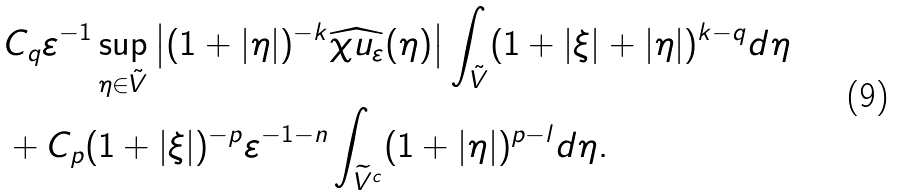<formula> <loc_0><loc_0><loc_500><loc_500>& C _ { q } \varepsilon ^ { - 1 } \sup _ { \eta \in \tilde { V } } \left | ( 1 + | \eta | ) ^ { - k } \widehat { \chi u _ { \varepsilon } } ( \eta ) \right | \int _ { \tilde { V } } ( 1 + | \xi | + | \eta | ) ^ { k - q } d \eta \\ & + C _ { p } ( 1 + | \xi | ) ^ { - p } \varepsilon ^ { - 1 - n } \int _ { \widetilde { V } ^ { c } } ( 1 + | \eta | ) ^ { p - l } d \eta .</formula> 